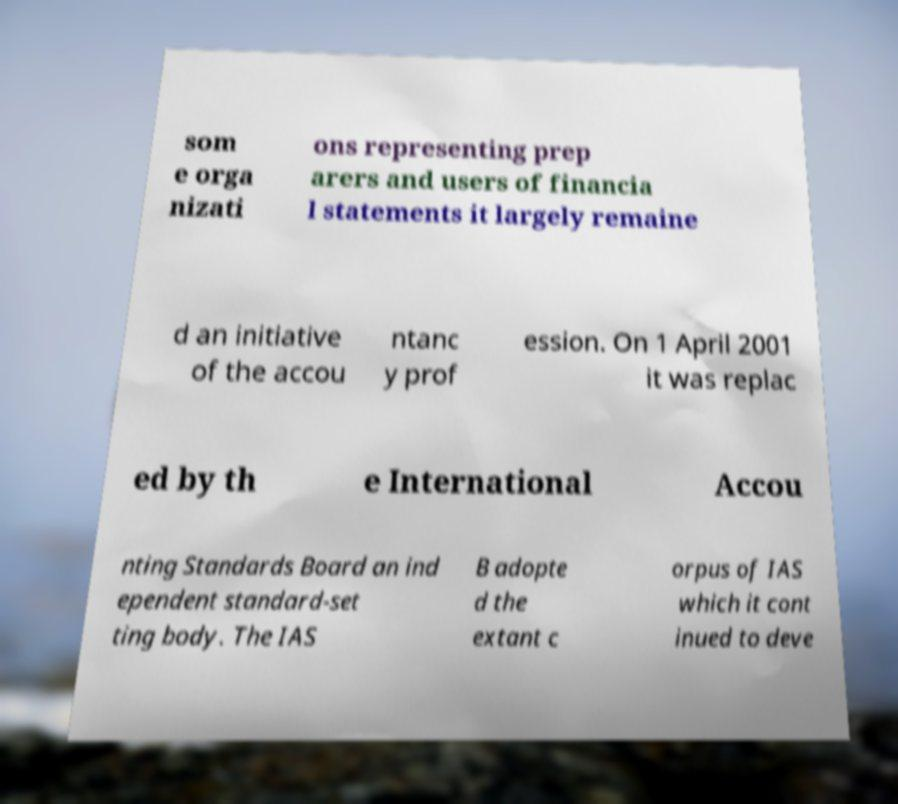Please identify and transcribe the text found in this image. som e orga nizati ons representing prep arers and users of financia l statements it largely remaine d an initiative of the accou ntanc y prof ession. On 1 April 2001 it was replac ed by th e International Accou nting Standards Board an ind ependent standard-set ting body. The IAS B adopte d the extant c orpus of IAS which it cont inued to deve 